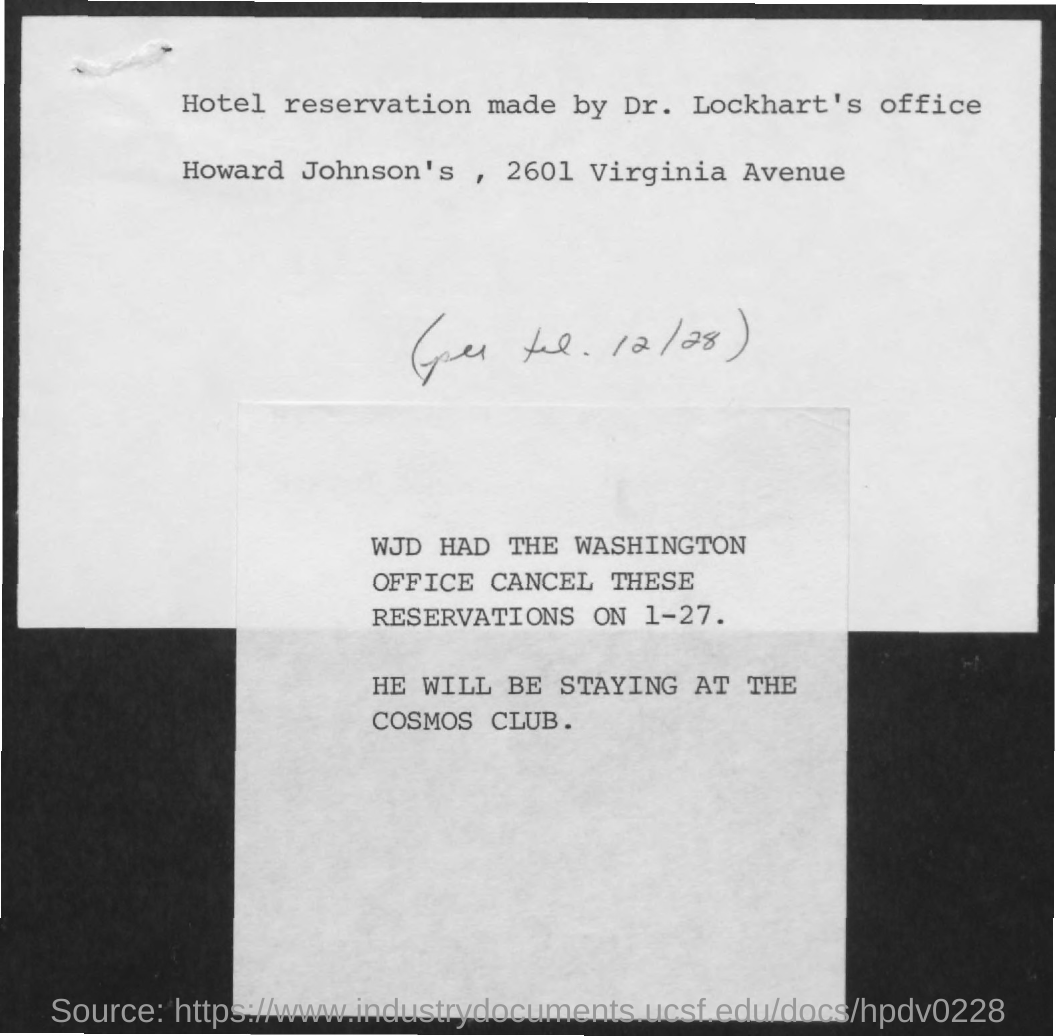Hotel Reservation Made by whom?
Keep it short and to the point. Dr. Lockhart's office. Where was the reservation made?
Your answer should be compact. Howard Johnson's, 2601 Virginia Avenue. When was the reservation cancelled?
Ensure brevity in your answer.  1-27. Where will he be staying?
Make the answer very short. Cosmos Club. 